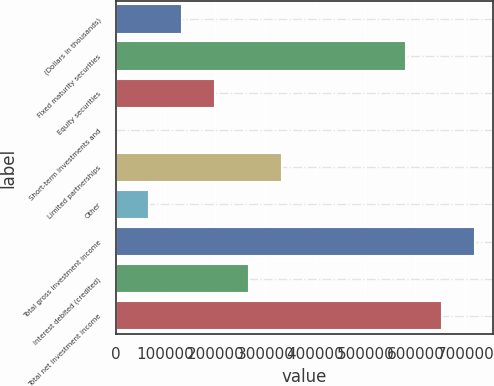<chart> <loc_0><loc_0><loc_500><loc_500><bar_chart><fcel>(Dollars in thousands)<fcel>Fixed maturity securities<fcel>Equity securities<fcel>Short-term investments and<fcel>Limited partnerships<fcel>Other<fcel>Total gross investment income<fcel>Interest debited (credited)<fcel>Total net investment income<nl><fcel>133368<fcel>581870<fcel>199976<fcel>151<fcel>333193<fcel>66759.4<fcel>720071<fcel>266585<fcel>653463<nl></chart> 